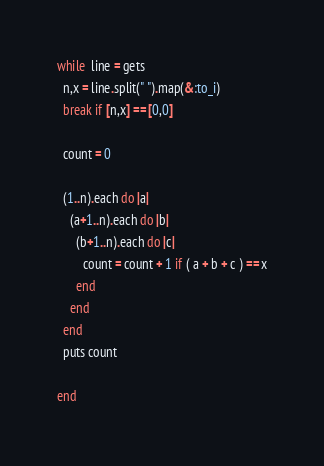Convert code to text. <code><loc_0><loc_0><loc_500><loc_500><_Ruby_>while  line = gets
  n,x = line.split(" ").map(&:to_i)
  break if [n,x] == [0,0]

  count = 0

  (1..n).each do |a|
    (a+1..n).each do |b|
      (b+1..n).each do |c|
        count = count + 1 if ( a + b + c ) == x
      end
    end
  end
  puts count

end</code> 